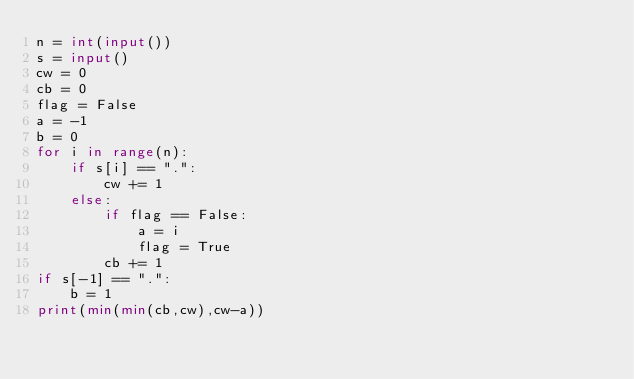<code> <loc_0><loc_0><loc_500><loc_500><_Python_>n = int(input())
s = input()
cw = 0
cb = 0
flag = False
a = -1
b = 0
for i in range(n):
    if s[i] == ".":
        cw += 1
    else:
        if flag == False:
            a = i
            flag = True
        cb += 1
if s[-1] == ".":
    b = 1
print(min(min(cb,cw),cw-a))
</code> 